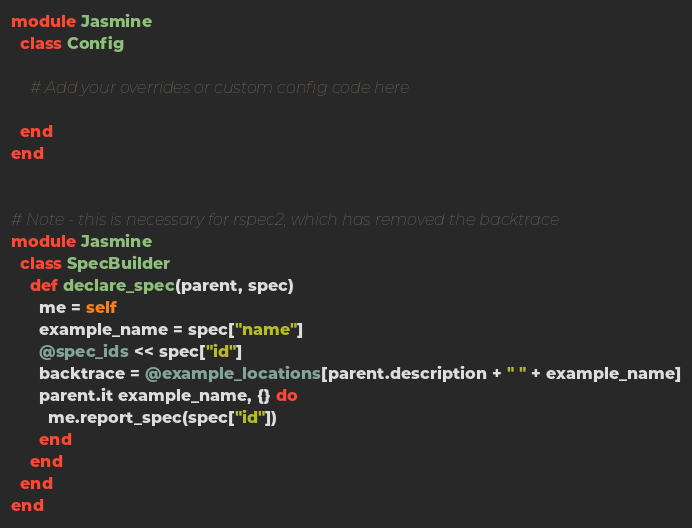Convert code to text. <code><loc_0><loc_0><loc_500><loc_500><_Ruby_>module Jasmine
  class Config

    # Add your overrides or custom config code here

  end
end


# Note - this is necessary for rspec2, which has removed the backtrace
module Jasmine
  class SpecBuilder
    def declare_spec(parent, spec)
      me = self
      example_name = spec["name"]
      @spec_ids << spec["id"]
      backtrace = @example_locations[parent.description + " " + example_name]
      parent.it example_name, {} do
        me.report_spec(spec["id"])
      end
    end
  end
end</code> 